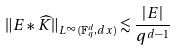Convert formula to latex. <formula><loc_0><loc_0><loc_500><loc_500>\| E \ast \widehat { K } \| _ { L ^ { \infty } ( { \mathbb { F } _ { q } ^ { d } } , d x ) } \lesssim \frac { | E | } { q ^ { d - 1 } }</formula> 